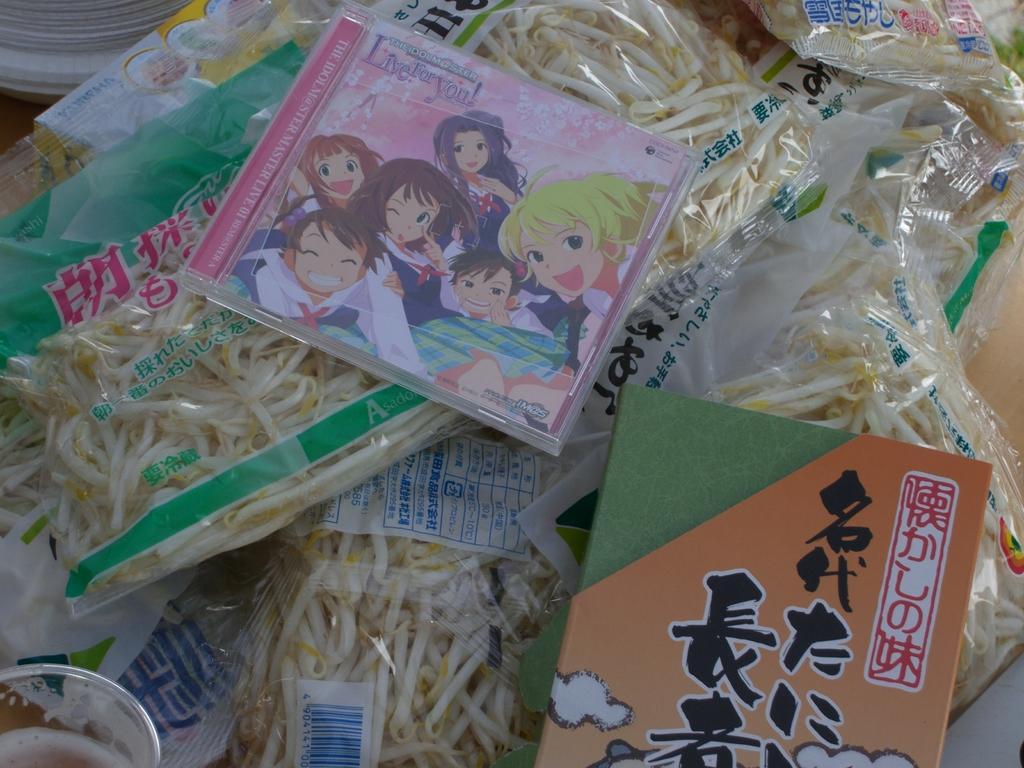Describe this image in one or two sentences. In this picture I can observe food packets. In the middle of the picture I can observe cartoon characters on the DVD box. 